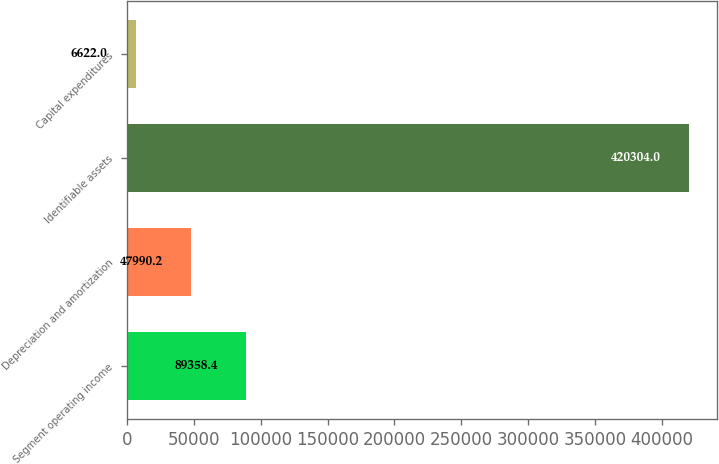<chart> <loc_0><loc_0><loc_500><loc_500><bar_chart><fcel>Segment operating income<fcel>Depreciation and amortization<fcel>Identifiable assets<fcel>Capital expenditures<nl><fcel>89358.4<fcel>47990.2<fcel>420304<fcel>6622<nl></chart> 